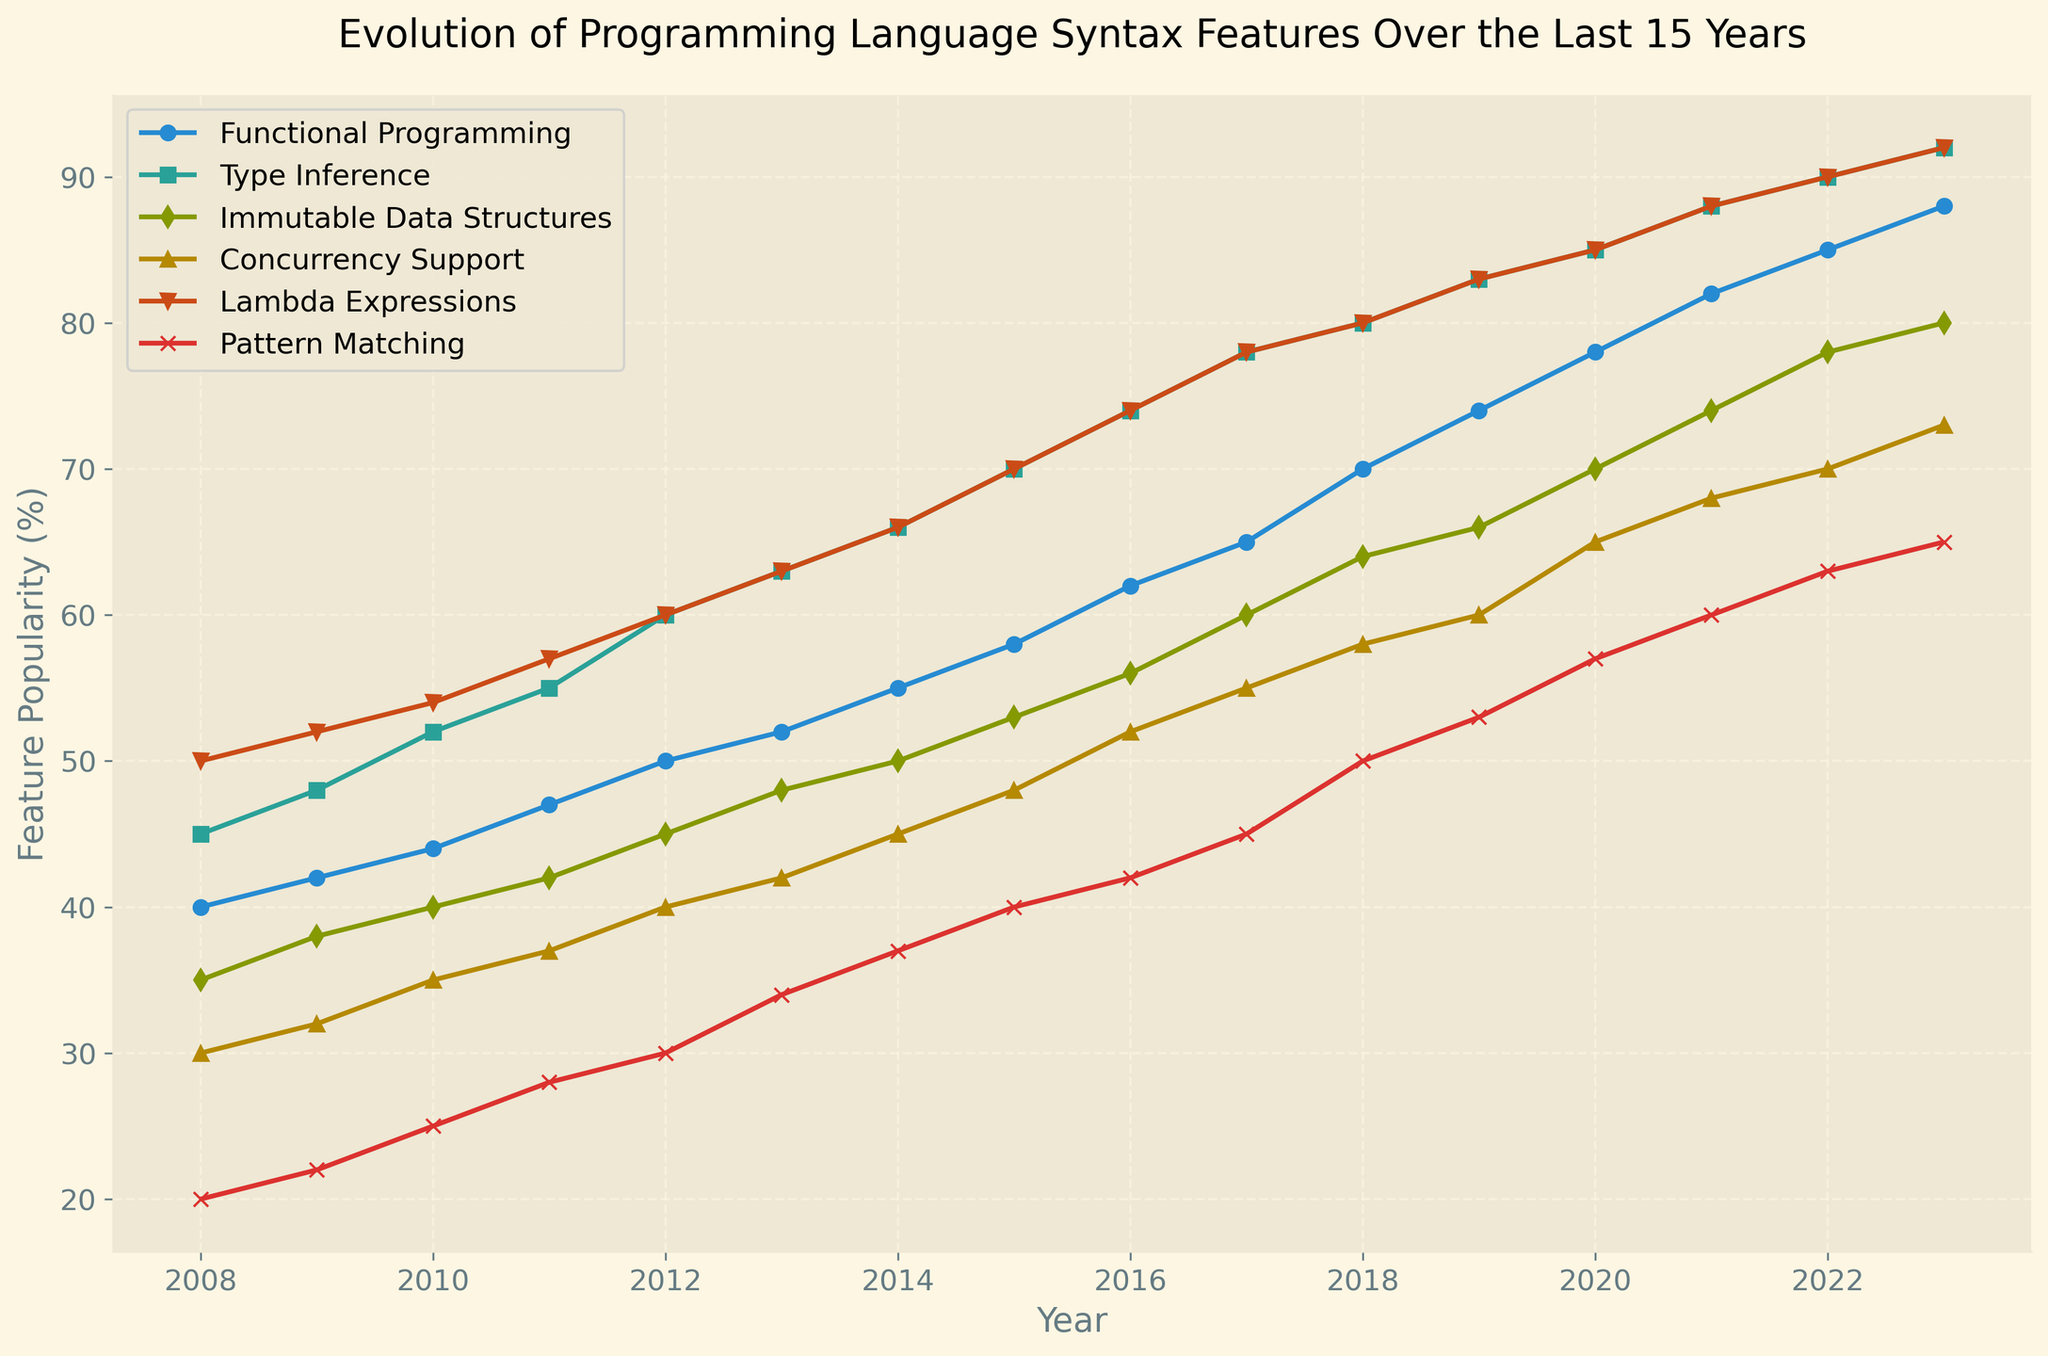what trend can be observed with lambda expressions over the years? By following the line representing lambda expressions from 2008 to 2023, we see that it consistently increases. From 2008's 50% to 2023's 92%, lambda expressions have become more popular each year.
Answer: Increasing trend Which feature had the highest percentage in 2012? In 2012, by comparing the percentages of all features, Lambda Expressions had the highest at 60%.
Answer: Lambda Expressions Did pattern matching surpass concurrency support in any year? By observing the lines for pattern matching and concurrency support, pattern matching consistently remains below concurrency support throughout all the years from 2008 to 2023.
Answer: No What is the difference in popularity between functional programming and immutable data structures in 2023? Looking at the endpoint values for 2023, functional programming is at 88% and immutable data structures are at 80%. The difference is calculated as 88% - 80%.
Answer: 8% What are the two most rapidly growing features over the 15 years? We can see the steepest slopes on the plot for the lines of Type Inference and Lambda Expressions, indicating rapid growth.
Answer: Type Inference and Lambda Expressions 